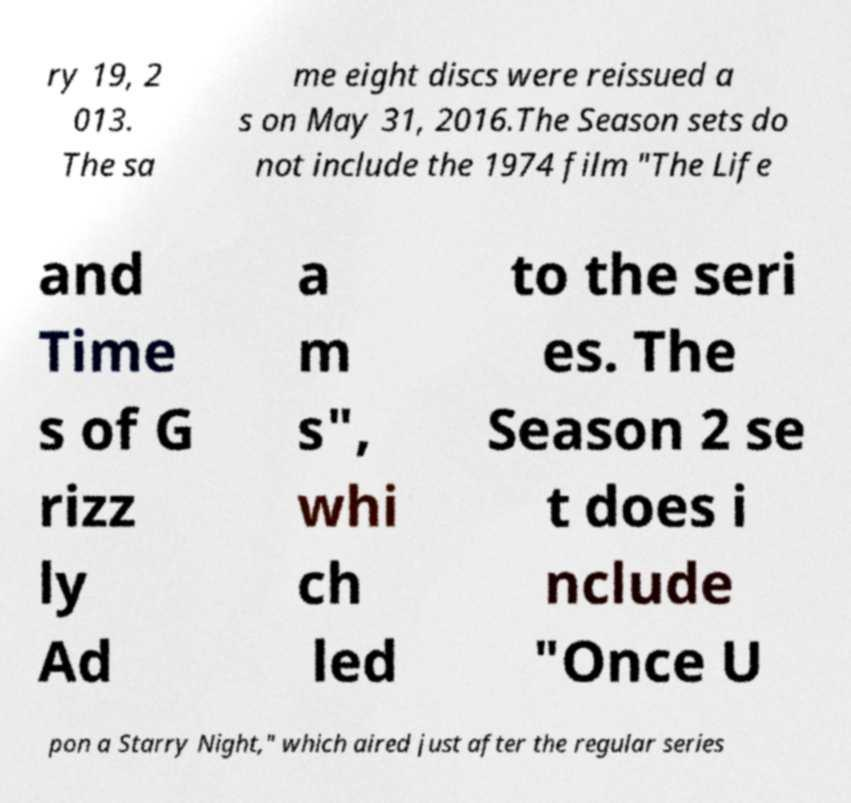Please read and relay the text visible in this image. What does it say? ry 19, 2 013. The sa me eight discs were reissued a s on May 31, 2016.The Season sets do not include the 1974 film "The Life and Time s of G rizz ly Ad a m s", whi ch led to the seri es. The Season 2 se t does i nclude "Once U pon a Starry Night," which aired just after the regular series 